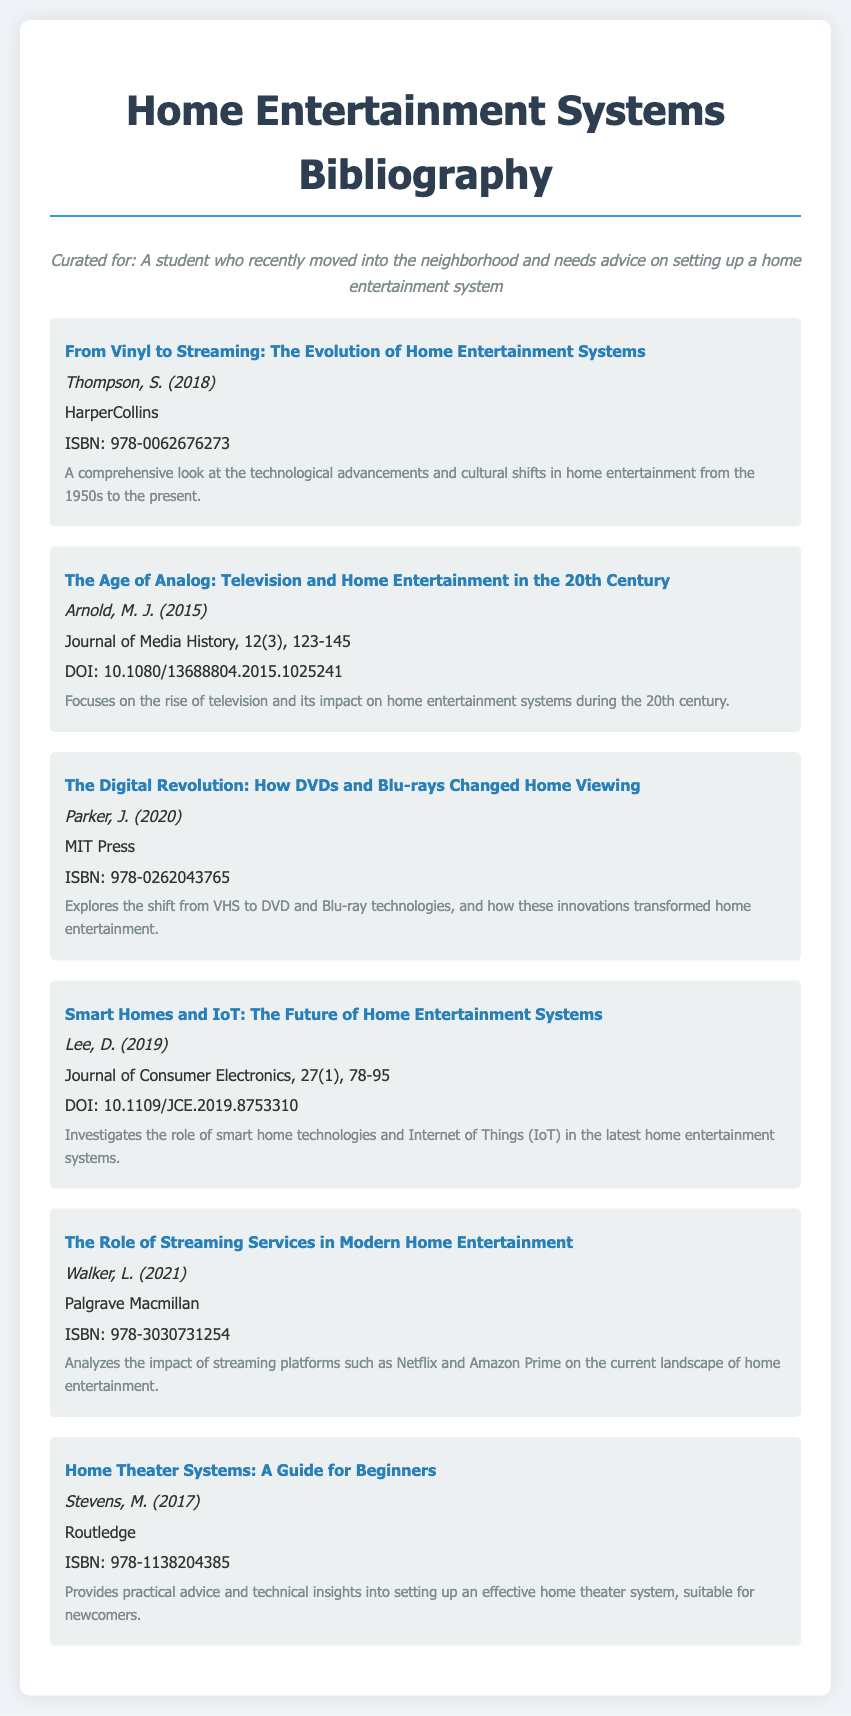What is the title of the book by Thompson? The title is found in the first bibliography item and is "From Vinyl to Streaming: The Evolution of Home Entertainment Systems."
Answer: From Vinyl to Streaming: The Evolution of Home Entertainment Systems Who authored the article "The Age of Analog"? The author is mentioned in the second bibliography entry, which is "Arnold, M. J."
Answer: Arnold, M. J What year was "The Digital Revolution" published? The publication year is specified in the third bibliography item as 2020.
Answer: 2020 What is the DOI for the article by Lee? The DOI is found in the fourth bibliography item, which is "10.1109/JCE.2019.8753310."
Answer: 10.1109/JCE.2019.8753310 Which press published "Home Theater Systems: A Guide for Beginners"? The publisher is indicated in the sixth item, which is "Routledge."
Answer: Routledge How many bibliography items mention smart home technologies? The fourth item focuses on smart homes, making it one item that mentions it.
Answer: One What type of publication is "The Age of Analog"? The type of publication is specified as an article in the "Journal of Media History."
Answer: Journal of Media History Which home entertainment innovations are discussed in the context of DVDs and Blu-rays? They are likely discussed in the third bibliography item, highlighting their transformative effects on home entertainment.
Answer: DVDs and Blu-rays What is the main focus of Walker's book? The main focus is indicated in the fifth item, analyzing the impact of streaming platforms on home entertainment.
Answer: Streaming platforms 